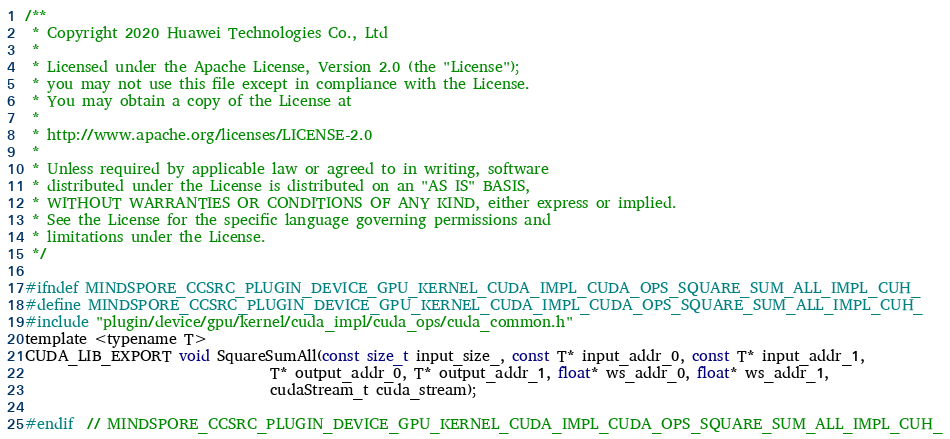Convert code to text. <code><loc_0><loc_0><loc_500><loc_500><_Cuda_>/**
 * Copyright 2020 Huawei Technologies Co., Ltd
 *
 * Licensed under the Apache License, Version 2.0 (the "License");
 * you may not use this file except in compliance with the License.
 * You may obtain a copy of the License at
 *
 * http://www.apache.org/licenses/LICENSE-2.0
 *
 * Unless required by applicable law or agreed to in writing, software
 * distributed under the License is distributed on an "AS IS" BASIS,
 * WITHOUT WARRANTIES OR CONDITIONS OF ANY KIND, either express or implied.
 * See the License for the specific language governing permissions and
 * limitations under the License.
 */

#ifndef MINDSPORE_CCSRC_PLUGIN_DEVICE_GPU_KERNEL_CUDA_IMPL_CUDA_OPS_SQUARE_SUM_ALL_IMPL_CUH_
#define MINDSPORE_CCSRC_PLUGIN_DEVICE_GPU_KERNEL_CUDA_IMPL_CUDA_OPS_SQUARE_SUM_ALL_IMPL_CUH_
#include "plugin/device/gpu/kernel/cuda_impl/cuda_ops/cuda_common.h"
template <typename T>
CUDA_LIB_EXPORT void SquareSumAll(const size_t input_size_, const T* input_addr_0, const T* input_addr_1,
                                  T* output_addr_0, T* output_addr_1, float* ws_addr_0, float* ws_addr_1,
                                  cudaStream_t cuda_stream);

#endif  // MINDSPORE_CCSRC_PLUGIN_DEVICE_GPU_KERNEL_CUDA_IMPL_CUDA_OPS_SQUARE_SUM_ALL_IMPL_CUH_
</code> 